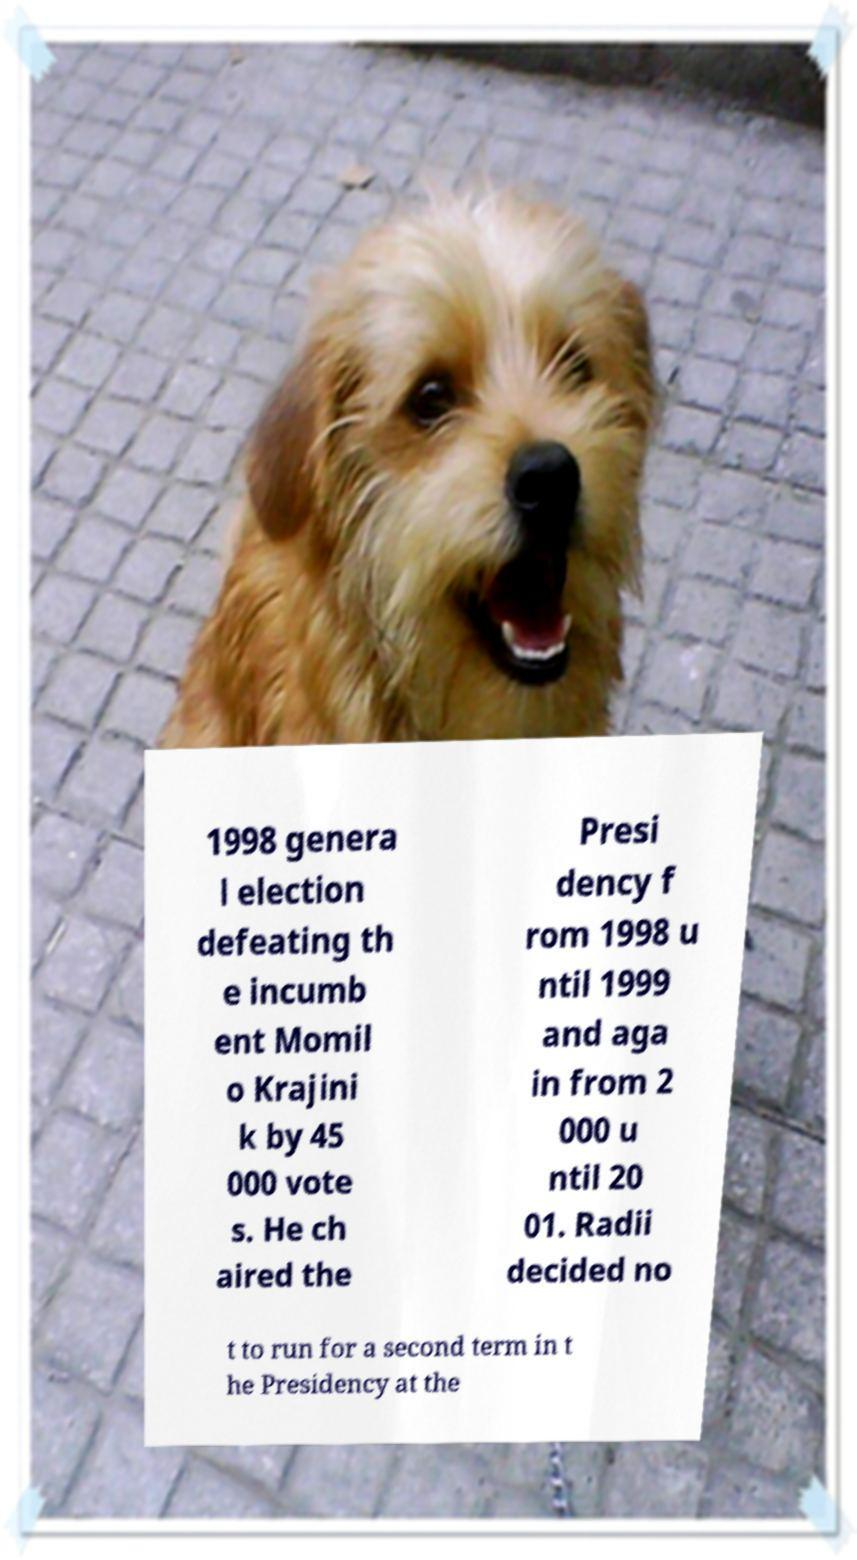For documentation purposes, I need the text within this image transcribed. Could you provide that? 1998 genera l election defeating th e incumb ent Momil o Krajini k by 45 000 vote s. He ch aired the Presi dency f rom 1998 u ntil 1999 and aga in from 2 000 u ntil 20 01. Radii decided no t to run for a second term in t he Presidency at the 